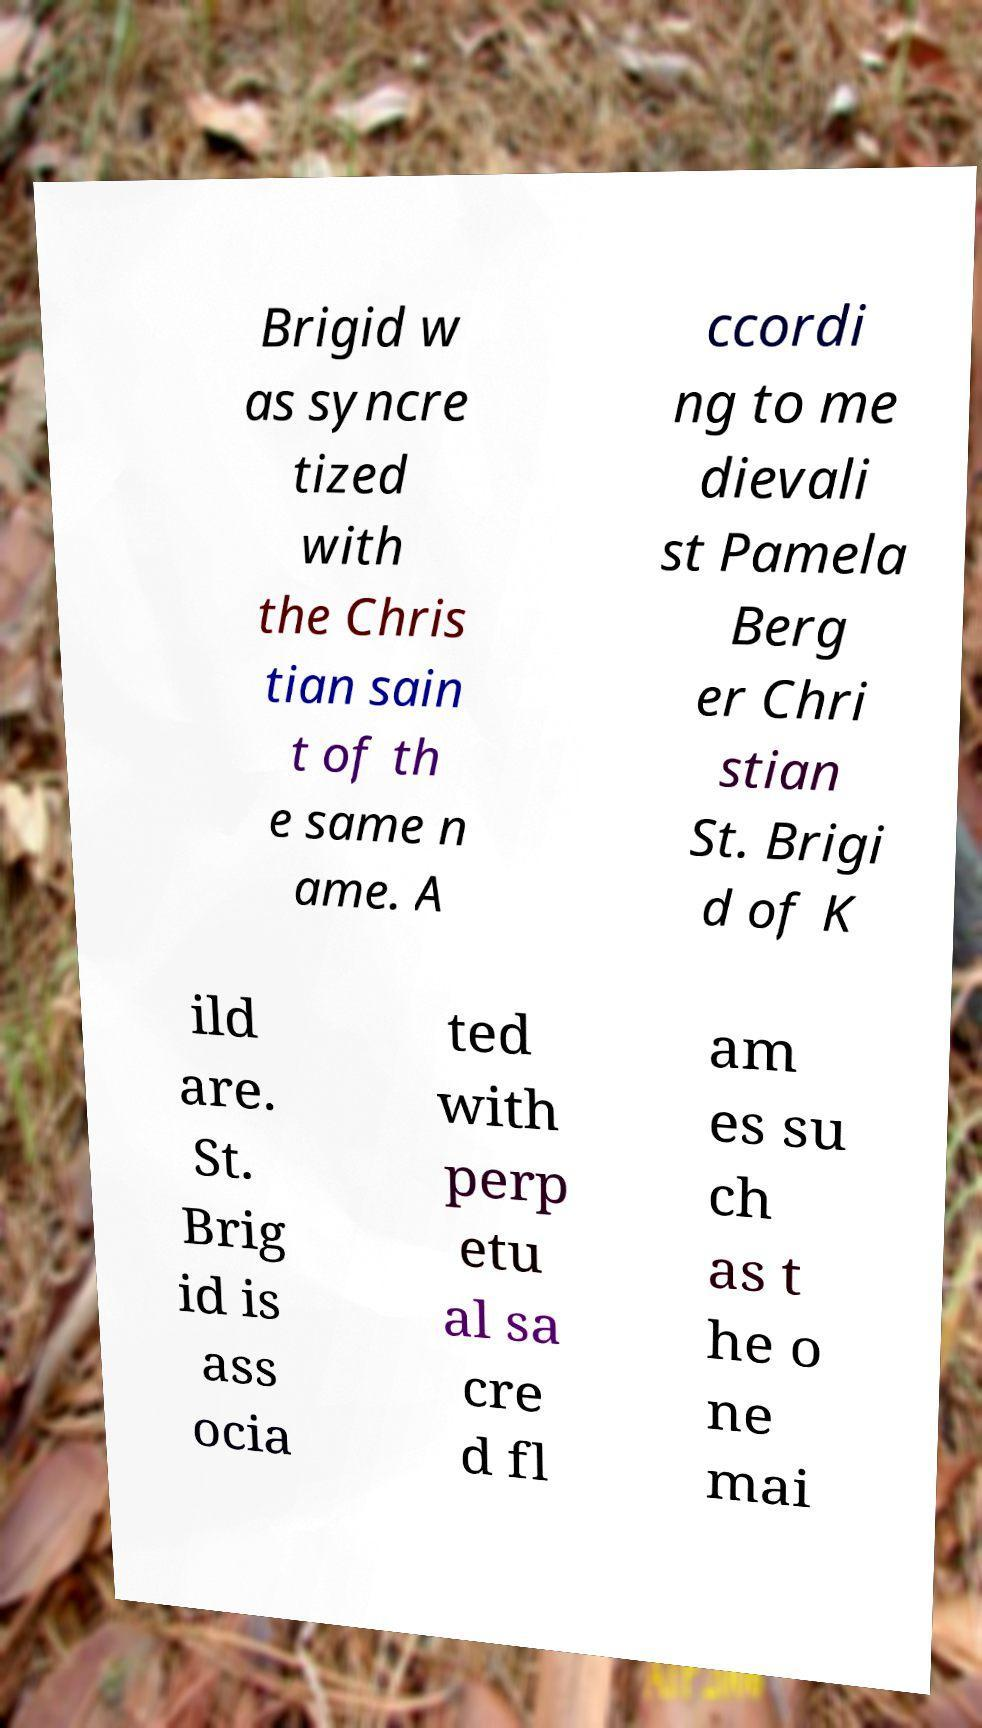For documentation purposes, I need the text within this image transcribed. Could you provide that? Brigid w as syncre tized with the Chris tian sain t of th e same n ame. A ccordi ng to me dievali st Pamela Berg er Chri stian St. Brigi d of K ild are. St. Brig id is ass ocia ted with perp etu al sa cre d fl am es su ch as t he o ne mai 